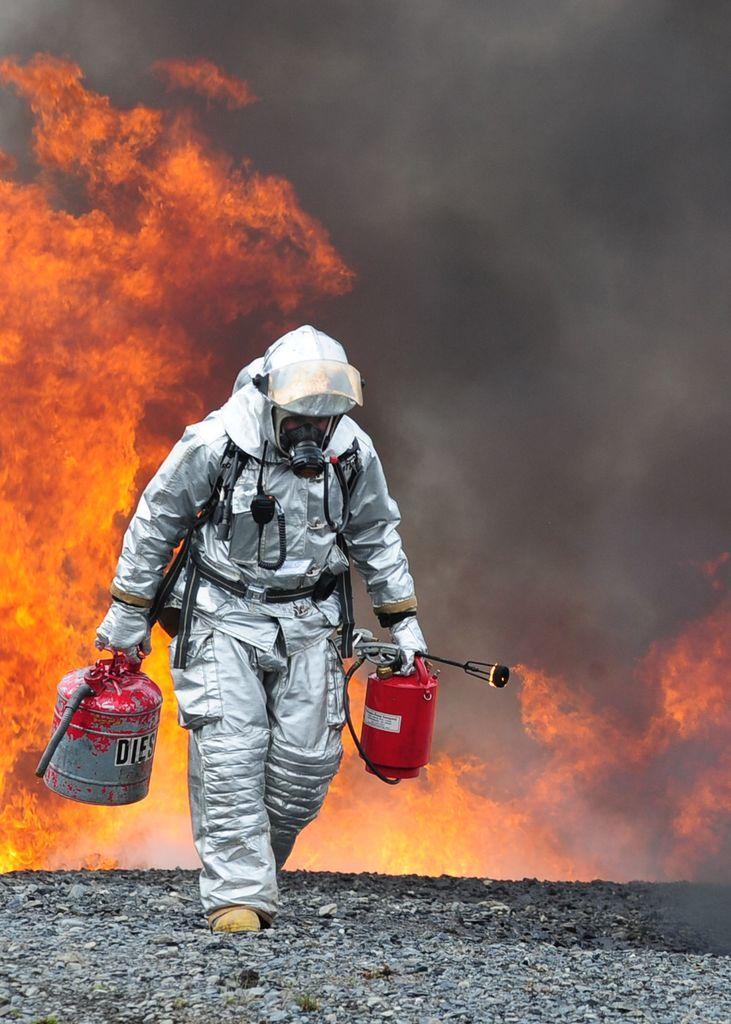In one or two sentences, can you explain what this image depicts? In this image we can see a person standing on the stones holding a diesel container and a fire extinguisher with his hands. On the backside we can see the fire with smoke. 